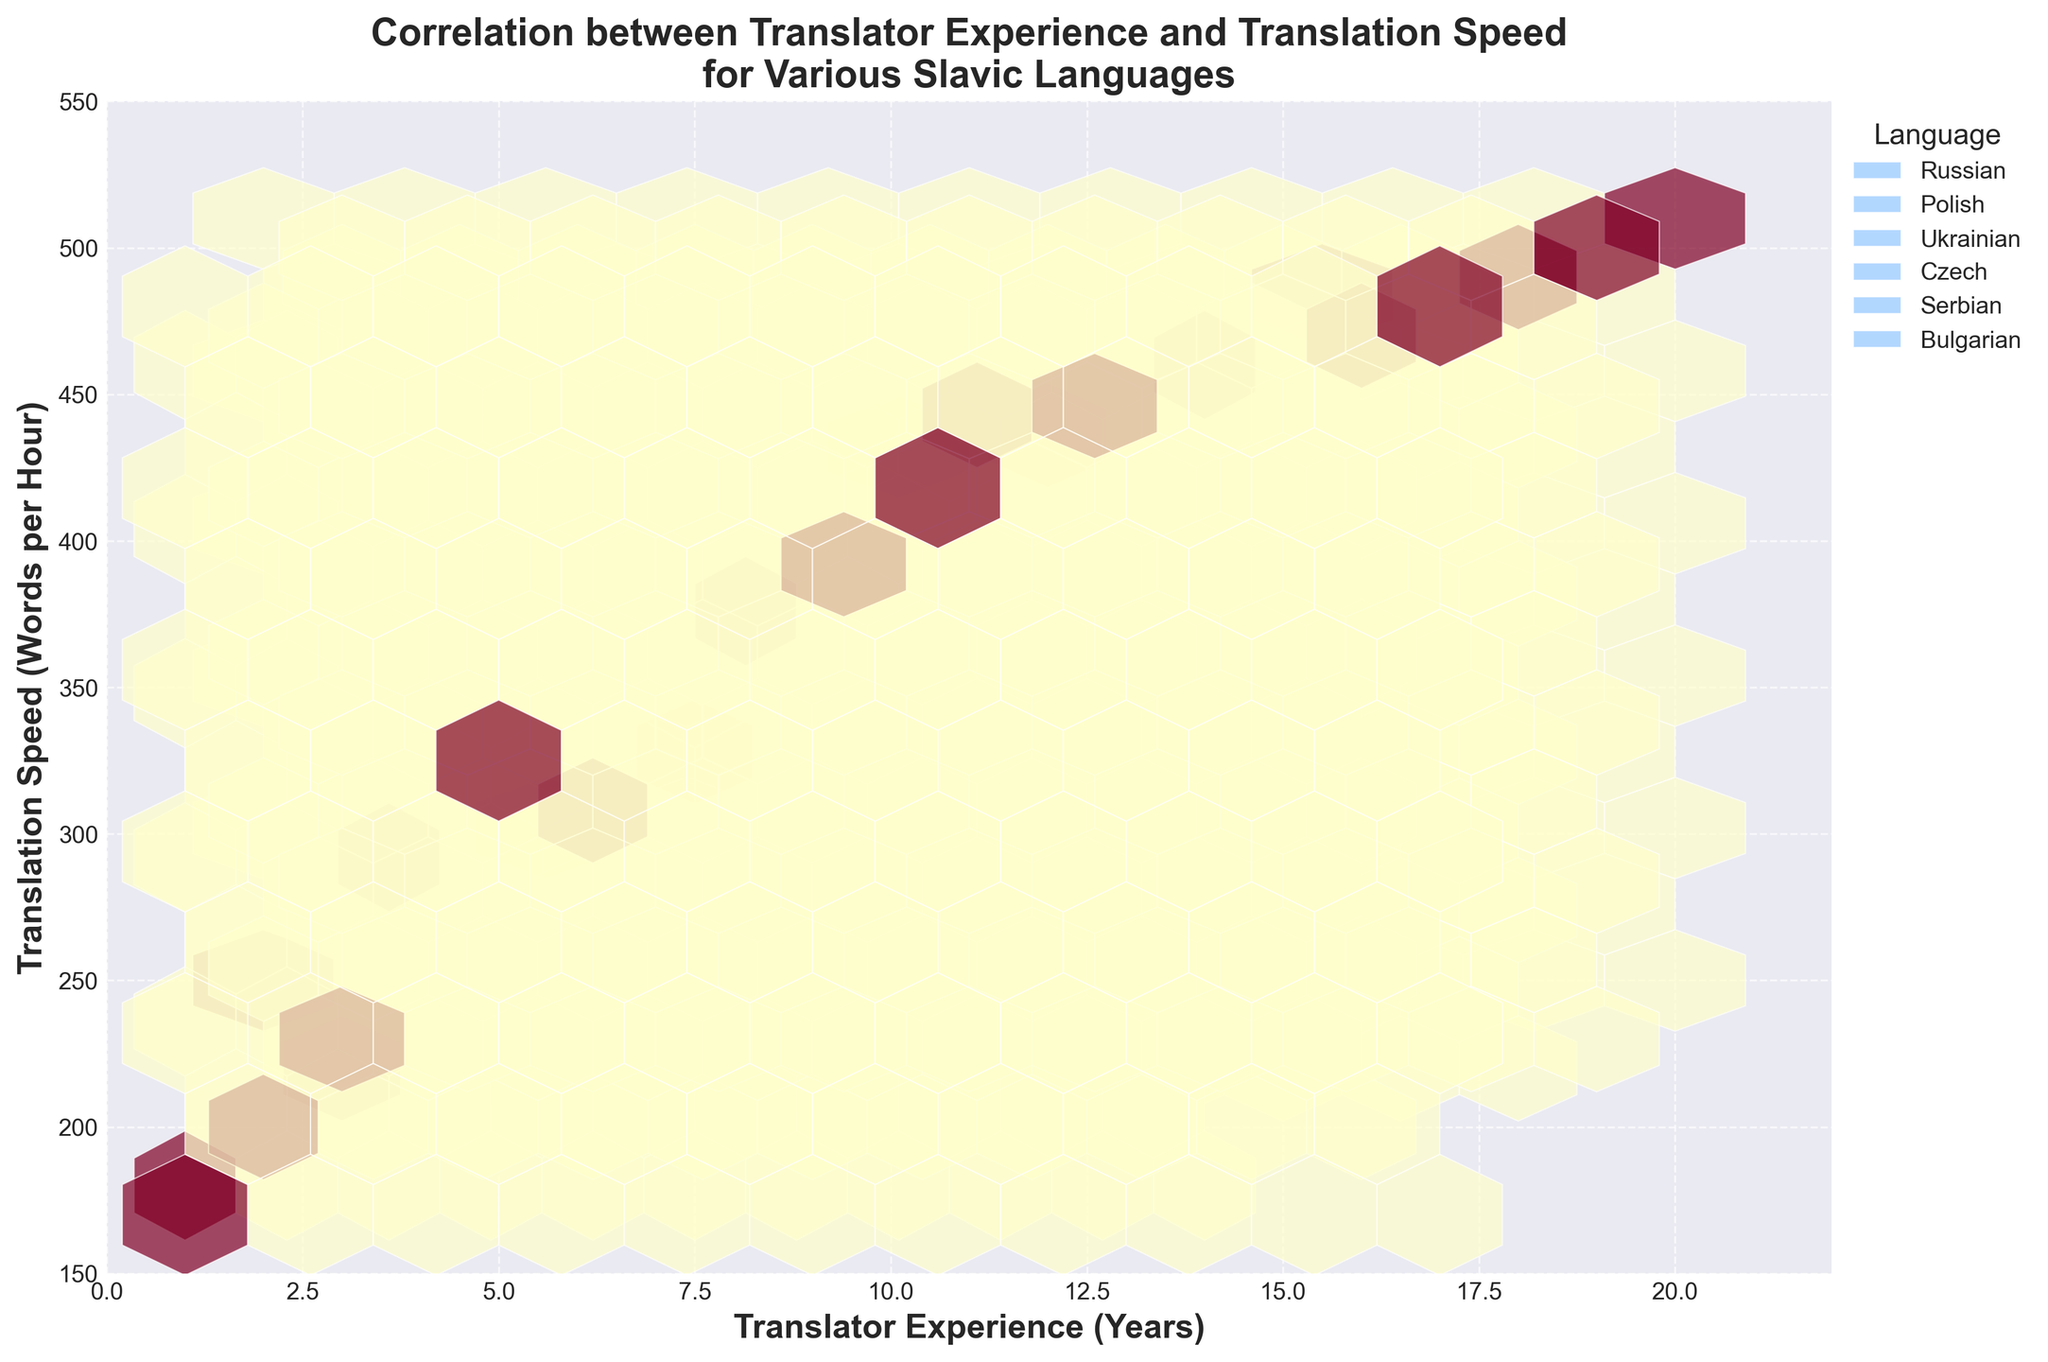What is the title of the hexbin plot? The title of the hexbin plot is usually displayed at the top of the figure and in bold font for emphasis. The title should reflect the key message or the relationship being visualized in the plot. Here, it's titled "Correlation between Translator Experience and Translation Speed for Various Slavic Languages" to highlight the comparison.
Answer: Correlation between Translator Experience and Translation Speed for Various Slavic Languages What are the x-axis and y-axis labels in the plot? Axis labels are necessary to describe the data being plotted. For this hexbin plot, the x-axis label is "Translator Experience (Years)" indicating the amount of experience translators have. The y-axis label is "Translation Speed (Words per Hour)" showing their speed in translating text.
Answer: x-axis: Translator Experience (Years), y-axis: Translation Speed (Words per Hour) Which language, according to the plot, has the highest translation speed for the most experienced translators? By observing the upper right part of the plot, the highest points for each language cluster are visible. The highest translation speed for highly experienced translators is seen in the Russian language cluster, where it reaches up to approximately 510 words per hour.
Answer: Russian What is the range of translator experience years for the Ukrainian language seen in the plot? The range can be determined by looking at the spread of the Ukrainian data points on the x-axis. The Ukrainian language dataset begins at 1 year of experience and goes up to 14 years of experience, covering a broad range.
Answer: 1 to 14 years Compare the translation speeds at 10 years of experience between Polish and Czech. Which language has a higher speed? By checking the 10-year experience vertical line, the corresponding translation speeds for Polish and Czech can be observed. Polish translators at 10 years have around 450 words per hour, while Czech translators have around 430 words per hour. Hence, Polish translators at 10 years of experience have a higher speed.
Answer: Polish What trend can you observe about translation speed as translator experience increases? The general trend in the hexbin plot shows that translation speeds tend to increase as translator experience years increase. Most languages demonstrate a positive correlation, where more experienced translators can translate more words per hour.
Answer: Translation speed increases with experience How do the data points of Serbian and Bulgarian compare in terms of translation speed at 10 years of experience? At 10 years of experience, the translation speed for Serbian is approximately 440 words per hour, whereas for Bulgarian, it is around 410 words per hour. Thus, Serbian translators have a higher translation speed at this experience level.
Answer: Serbian What is the approximate range of translation speeds for the least experienced translators in the dataset (0-2 years)? To determine this, we look at the lower end of the experience range (0-2 years) on the x-axis and observe the spread on the y-axis. Translation speeds for beginners range from approximately 170 to 250 words per hour.
Answer: 170 to 250 words per hour How many Slavic languages are represented in the hexbin plot? The number of unique colors in the legend and the distinct clusters in the hexbin plot indicate the languages. By checking the legend on the right, we see six languages: Russian, Polish, Ukrainian, Czech, Serbian, and Bulgarian.
Answer: Six 